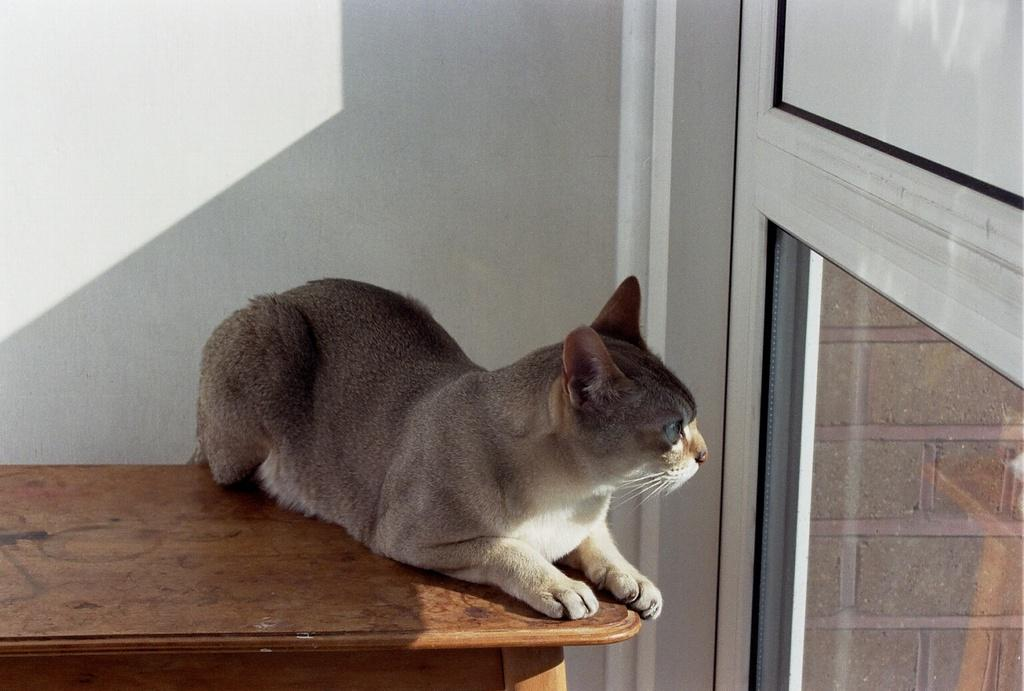What type of furniture is in the image? There is a table in the image. What animal can be seen on the table? A cat is present on the table. What type of door is visible on the right side of the image? There is a glass door on the right side of the image. How many balloons are tied to the cat's tail in the image? There are no balloons present in the image, and the cat's tail is not tied to any balloons. What type of zipper can be seen on the cat's fur in the image? There is no zipper present on the cat's fur in the image. 